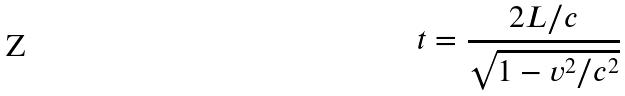<formula> <loc_0><loc_0><loc_500><loc_500>t = \frac { 2 L / c } { \sqrt { 1 - v ^ { 2 } / c ^ { 2 } } }</formula> 